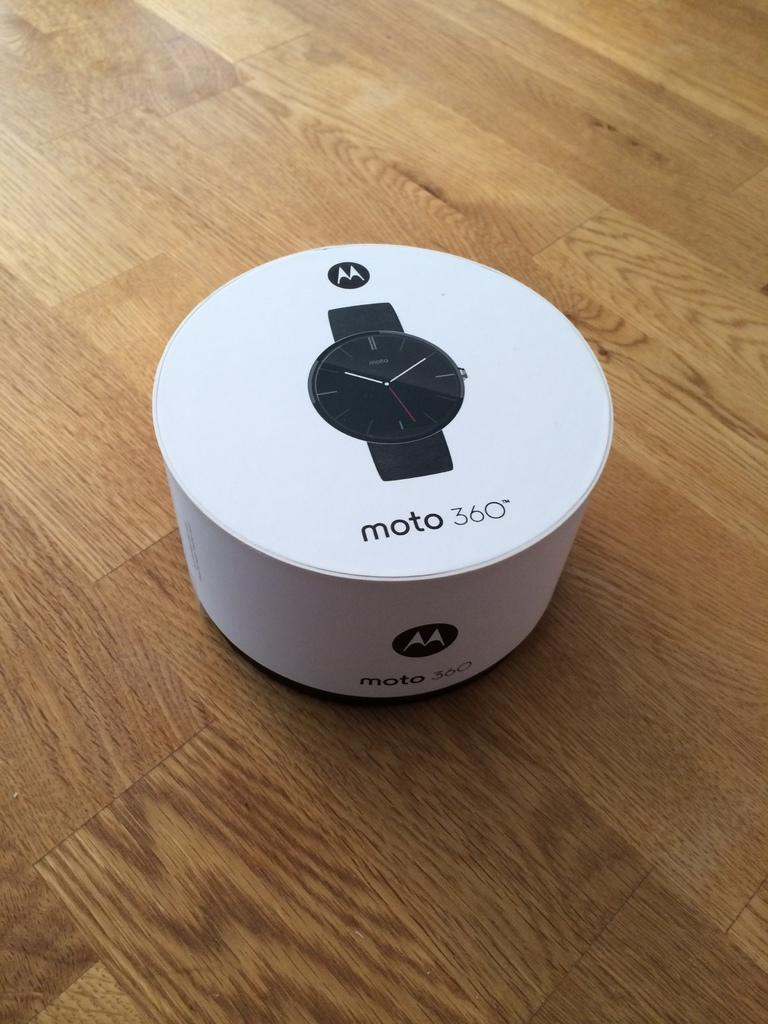<image>
Provide a brief description of the given image. A box with the picture of a Moto 360 watch on it. 